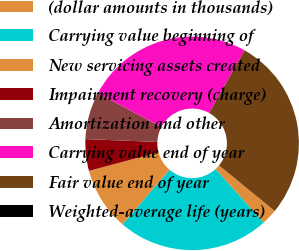<chart> <loc_0><loc_0><loc_500><loc_500><pie_chart><fcel>(dollar amounts in thousands)<fcel>Carrying value beginning of<fcel>New servicing assets created<fcel>Impairment recovery (charge)<fcel>Amortization and other<fcel>Carrying value end of year<fcel>Fair value end of year<fcel>Weighted-average life (years)<nl><fcel>2.39%<fcel>22.98%<fcel>9.55%<fcel>4.78%<fcel>7.16%<fcel>25.37%<fcel>27.76%<fcel>0.0%<nl></chart> 